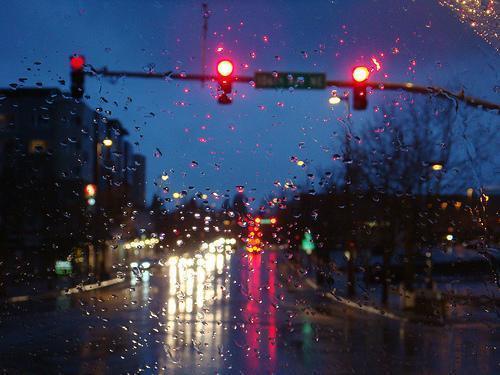How many lights are at the intersection?
Give a very brief answer. 3. How many people are in this picture?
Give a very brief answer. 0. 